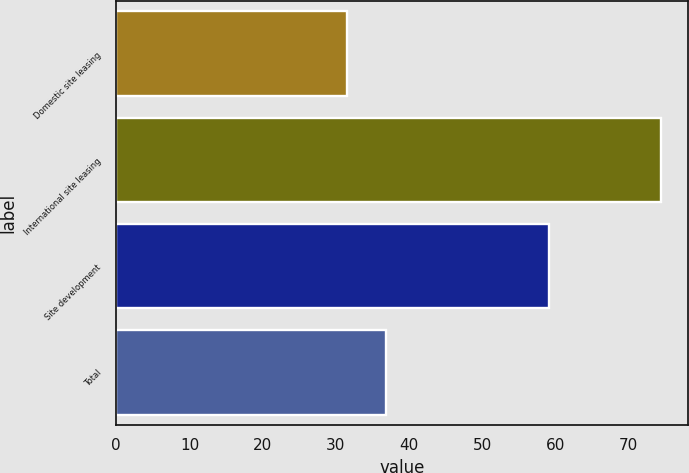Convert chart to OTSL. <chart><loc_0><loc_0><loc_500><loc_500><bar_chart><fcel>Domestic site leasing<fcel>International site leasing<fcel>Site development<fcel>Total<nl><fcel>31.5<fcel>74.4<fcel>59.1<fcel>36.8<nl></chart> 